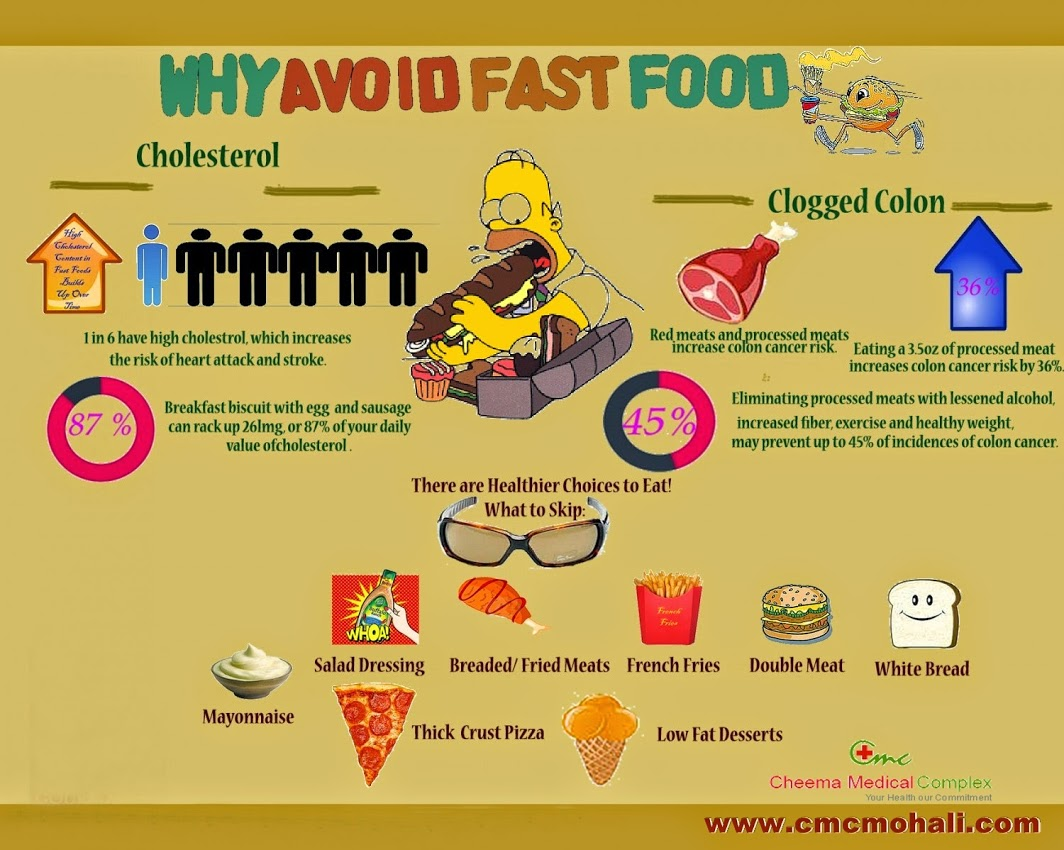Can you describe the role of exercise in maintaining a healthy weight according to the infographic? According to the infographic, exercise plays a crucial role in maintaining a healthy weight, which is one of the strategies to prevent colon cancer. Regular physical activity helps burn calories, reduce body fat, and build muscle, all contributing to a healthy weight. Exercise also improves metabolism and supports overall physical and mental health, making it a vital component of a comprehensive approach to cancer prevention and general wellness. What can happen if one continues to eat processed meats regularly? Continuing to eat processed meats regularly can significantly increase health risks. The infographic indicates that consuming 3.5 ounces of processed meat daily can increase the risk of colon cancer by 36%. Additionally, regular consumption of processed meats is associated with higher levels of harmful compounds like nitrates and nitrites, which can contribute to the development of cancer. It is also linked to other health issues such as heart disease, obesity, and diabetes. Imagine you are a health detective investigating the scene at a fast-food diner. What might you find that indicates an increased risk of health issues? As a health detective investigating a fast-food diner, I would observe a menu full of high-cholesterol items like breakfast biscuits with egg and sausage, which can rack up 87% of your daily value of cholesterol. There would be mayonnaise-laden dishes, salad dressings with hidden fats, and breaded or fried meats. French fries, dense in unhealthy fats and calories, double meat burgers loaded with saturated fats, and thick crust pizzas might dominate the menu. White bread, lacking in fiber and nutrients, along with seemingly 'low-fat' desserts, often packed with sugars, would be readily available, painting a picture of nutritional peril contributing to obesity, heart disease, and increased cancer risks. 